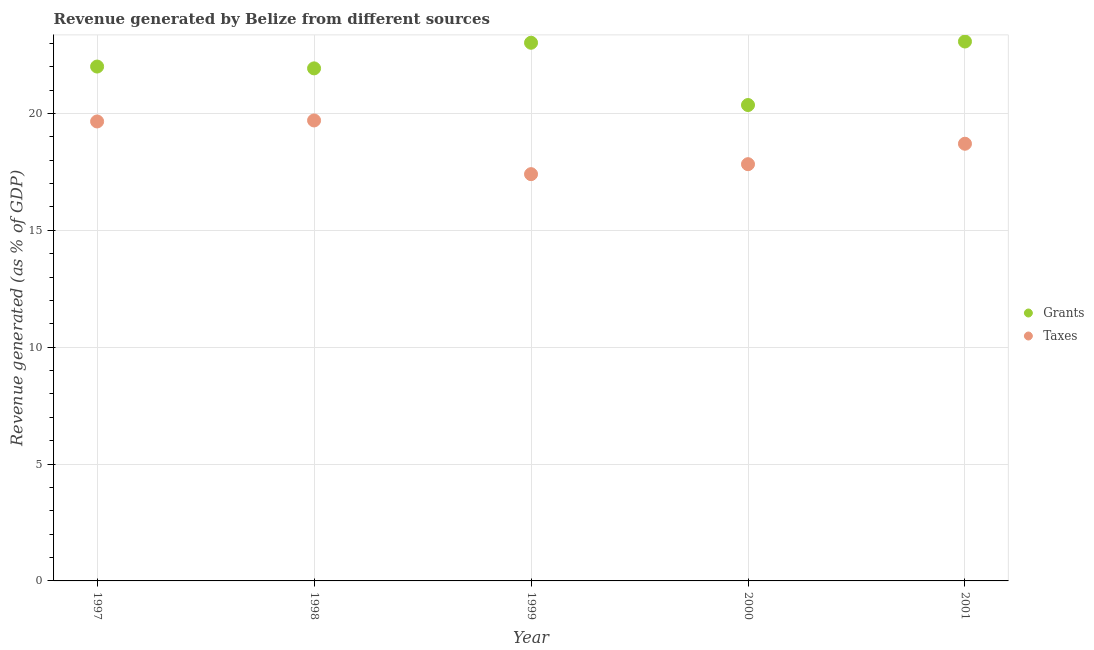What is the revenue generated by grants in 2000?
Offer a very short reply. 20.36. Across all years, what is the maximum revenue generated by taxes?
Offer a very short reply. 19.7. Across all years, what is the minimum revenue generated by grants?
Ensure brevity in your answer.  20.36. What is the total revenue generated by taxes in the graph?
Your response must be concise. 93.28. What is the difference between the revenue generated by grants in 1998 and that in 2001?
Your answer should be compact. -1.15. What is the difference between the revenue generated by taxes in 2001 and the revenue generated by grants in 1998?
Provide a short and direct response. -3.22. What is the average revenue generated by grants per year?
Offer a very short reply. 22.08. In the year 2001, what is the difference between the revenue generated by taxes and revenue generated by grants?
Provide a succinct answer. -4.37. In how many years, is the revenue generated by grants greater than 1 %?
Provide a succinct answer. 5. What is the ratio of the revenue generated by taxes in 2000 to that in 2001?
Give a very brief answer. 0.95. What is the difference between the highest and the second highest revenue generated by grants?
Your answer should be very brief. 0.05. What is the difference between the highest and the lowest revenue generated by grants?
Your answer should be compact. 2.72. Is the revenue generated by grants strictly less than the revenue generated by taxes over the years?
Provide a succinct answer. No. How many years are there in the graph?
Give a very brief answer. 5. What is the difference between two consecutive major ticks on the Y-axis?
Make the answer very short. 5. Are the values on the major ticks of Y-axis written in scientific E-notation?
Your response must be concise. No. Does the graph contain grids?
Ensure brevity in your answer.  Yes. Where does the legend appear in the graph?
Make the answer very short. Center right. How are the legend labels stacked?
Your answer should be very brief. Vertical. What is the title of the graph?
Provide a succinct answer. Revenue generated by Belize from different sources. Does "Nonresident" appear as one of the legend labels in the graph?
Provide a short and direct response. No. What is the label or title of the X-axis?
Ensure brevity in your answer.  Year. What is the label or title of the Y-axis?
Make the answer very short. Revenue generated (as % of GDP). What is the Revenue generated (as % of GDP) of Grants in 1997?
Your response must be concise. 22. What is the Revenue generated (as % of GDP) of Taxes in 1997?
Your response must be concise. 19.66. What is the Revenue generated (as % of GDP) of Grants in 1998?
Provide a short and direct response. 21.93. What is the Revenue generated (as % of GDP) in Taxes in 1998?
Provide a succinct answer. 19.7. What is the Revenue generated (as % of GDP) in Grants in 1999?
Ensure brevity in your answer.  23.02. What is the Revenue generated (as % of GDP) in Taxes in 1999?
Provide a short and direct response. 17.4. What is the Revenue generated (as % of GDP) in Grants in 2000?
Provide a short and direct response. 20.36. What is the Revenue generated (as % of GDP) of Taxes in 2000?
Offer a terse response. 17.83. What is the Revenue generated (as % of GDP) in Grants in 2001?
Provide a succinct answer. 23.08. What is the Revenue generated (as % of GDP) of Taxes in 2001?
Provide a short and direct response. 18.7. Across all years, what is the maximum Revenue generated (as % of GDP) in Grants?
Offer a terse response. 23.08. Across all years, what is the maximum Revenue generated (as % of GDP) of Taxes?
Ensure brevity in your answer.  19.7. Across all years, what is the minimum Revenue generated (as % of GDP) of Grants?
Your response must be concise. 20.36. Across all years, what is the minimum Revenue generated (as % of GDP) of Taxes?
Your response must be concise. 17.4. What is the total Revenue generated (as % of GDP) of Grants in the graph?
Provide a short and direct response. 110.39. What is the total Revenue generated (as % of GDP) in Taxes in the graph?
Make the answer very short. 93.28. What is the difference between the Revenue generated (as % of GDP) in Grants in 1997 and that in 1998?
Offer a terse response. 0.08. What is the difference between the Revenue generated (as % of GDP) of Taxes in 1997 and that in 1998?
Your response must be concise. -0.04. What is the difference between the Revenue generated (as % of GDP) of Grants in 1997 and that in 1999?
Offer a terse response. -1.02. What is the difference between the Revenue generated (as % of GDP) of Taxes in 1997 and that in 1999?
Your response must be concise. 2.25. What is the difference between the Revenue generated (as % of GDP) of Grants in 1997 and that in 2000?
Offer a very short reply. 1.65. What is the difference between the Revenue generated (as % of GDP) of Taxes in 1997 and that in 2000?
Offer a very short reply. 1.83. What is the difference between the Revenue generated (as % of GDP) of Grants in 1997 and that in 2001?
Provide a short and direct response. -1.07. What is the difference between the Revenue generated (as % of GDP) of Taxes in 1997 and that in 2001?
Give a very brief answer. 0.95. What is the difference between the Revenue generated (as % of GDP) of Grants in 1998 and that in 1999?
Your answer should be compact. -1.1. What is the difference between the Revenue generated (as % of GDP) of Taxes in 1998 and that in 1999?
Your answer should be very brief. 2.3. What is the difference between the Revenue generated (as % of GDP) in Grants in 1998 and that in 2000?
Keep it short and to the point. 1.57. What is the difference between the Revenue generated (as % of GDP) in Taxes in 1998 and that in 2000?
Make the answer very short. 1.87. What is the difference between the Revenue generated (as % of GDP) of Grants in 1998 and that in 2001?
Ensure brevity in your answer.  -1.15. What is the difference between the Revenue generated (as % of GDP) in Grants in 1999 and that in 2000?
Offer a very short reply. 2.66. What is the difference between the Revenue generated (as % of GDP) of Taxes in 1999 and that in 2000?
Ensure brevity in your answer.  -0.43. What is the difference between the Revenue generated (as % of GDP) of Grants in 1999 and that in 2001?
Provide a short and direct response. -0.05. What is the difference between the Revenue generated (as % of GDP) of Taxes in 1999 and that in 2001?
Your response must be concise. -1.3. What is the difference between the Revenue generated (as % of GDP) of Grants in 2000 and that in 2001?
Make the answer very short. -2.72. What is the difference between the Revenue generated (as % of GDP) of Taxes in 2000 and that in 2001?
Offer a very short reply. -0.87. What is the difference between the Revenue generated (as % of GDP) in Grants in 1997 and the Revenue generated (as % of GDP) in Taxes in 1998?
Your answer should be compact. 2.31. What is the difference between the Revenue generated (as % of GDP) in Grants in 1997 and the Revenue generated (as % of GDP) in Taxes in 1999?
Your response must be concise. 4.6. What is the difference between the Revenue generated (as % of GDP) of Grants in 1997 and the Revenue generated (as % of GDP) of Taxes in 2000?
Provide a succinct answer. 4.18. What is the difference between the Revenue generated (as % of GDP) of Grants in 1997 and the Revenue generated (as % of GDP) of Taxes in 2001?
Make the answer very short. 3.3. What is the difference between the Revenue generated (as % of GDP) in Grants in 1998 and the Revenue generated (as % of GDP) in Taxes in 1999?
Keep it short and to the point. 4.52. What is the difference between the Revenue generated (as % of GDP) in Grants in 1998 and the Revenue generated (as % of GDP) in Taxes in 2000?
Your answer should be very brief. 4.1. What is the difference between the Revenue generated (as % of GDP) in Grants in 1998 and the Revenue generated (as % of GDP) in Taxes in 2001?
Ensure brevity in your answer.  3.22. What is the difference between the Revenue generated (as % of GDP) of Grants in 1999 and the Revenue generated (as % of GDP) of Taxes in 2000?
Ensure brevity in your answer.  5.19. What is the difference between the Revenue generated (as % of GDP) in Grants in 1999 and the Revenue generated (as % of GDP) in Taxes in 2001?
Offer a very short reply. 4.32. What is the difference between the Revenue generated (as % of GDP) of Grants in 2000 and the Revenue generated (as % of GDP) of Taxes in 2001?
Ensure brevity in your answer.  1.66. What is the average Revenue generated (as % of GDP) in Grants per year?
Ensure brevity in your answer.  22.08. What is the average Revenue generated (as % of GDP) in Taxes per year?
Make the answer very short. 18.66. In the year 1997, what is the difference between the Revenue generated (as % of GDP) of Grants and Revenue generated (as % of GDP) of Taxes?
Provide a succinct answer. 2.35. In the year 1998, what is the difference between the Revenue generated (as % of GDP) in Grants and Revenue generated (as % of GDP) in Taxes?
Keep it short and to the point. 2.23. In the year 1999, what is the difference between the Revenue generated (as % of GDP) in Grants and Revenue generated (as % of GDP) in Taxes?
Offer a terse response. 5.62. In the year 2000, what is the difference between the Revenue generated (as % of GDP) of Grants and Revenue generated (as % of GDP) of Taxes?
Your answer should be very brief. 2.53. In the year 2001, what is the difference between the Revenue generated (as % of GDP) of Grants and Revenue generated (as % of GDP) of Taxes?
Offer a very short reply. 4.37. What is the ratio of the Revenue generated (as % of GDP) of Grants in 1997 to that in 1999?
Keep it short and to the point. 0.96. What is the ratio of the Revenue generated (as % of GDP) of Taxes in 1997 to that in 1999?
Offer a very short reply. 1.13. What is the ratio of the Revenue generated (as % of GDP) of Grants in 1997 to that in 2000?
Offer a very short reply. 1.08. What is the ratio of the Revenue generated (as % of GDP) in Taxes in 1997 to that in 2000?
Provide a succinct answer. 1.1. What is the ratio of the Revenue generated (as % of GDP) in Grants in 1997 to that in 2001?
Offer a very short reply. 0.95. What is the ratio of the Revenue generated (as % of GDP) of Taxes in 1997 to that in 2001?
Offer a very short reply. 1.05. What is the ratio of the Revenue generated (as % of GDP) in Grants in 1998 to that in 1999?
Ensure brevity in your answer.  0.95. What is the ratio of the Revenue generated (as % of GDP) of Taxes in 1998 to that in 1999?
Your response must be concise. 1.13. What is the ratio of the Revenue generated (as % of GDP) in Grants in 1998 to that in 2000?
Make the answer very short. 1.08. What is the ratio of the Revenue generated (as % of GDP) in Taxes in 1998 to that in 2000?
Your answer should be compact. 1.1. What is the ratio of the Revenue generated (as % of GDP) of Grants in 1998 to that in 2001?
Give a very brief answer. 0.95. What is the ratio of the Revenue generated (as % of GDP) of Taxes in 1998 to that in 2001?
Provide a succinct answer. 1.05. What is the ratio of the Revenue generated (as % of GDP) of Grants in 1999 to that in 2000?
Your answer should be compact. 1.13. What is the ratio of the Revenue generated (as % of GDP) in Taxes in 1999 to that in 2000?
Your answer should be compact. 0.98. What is the ratio of the Revenue generated (as % of GDP) of Taxes in 1999 to that in 2001?
Make the answer very short. 0.93. What is the ratio of the Revenue generated (as % of GDP) of Grants in 2000 to that in 2001?
Keep it short and to the point. 0.88. What is the ratio of the Revenue generated (as % of GDP) of Taxes in 2000 to that in 2001?
Offer a very short reply. 0.95. What is the difference between the highest and the second highest Revenue generated (as % of GDP) in Grants?
Keep it short and to the point. 0.05. What is the difference between the highest and the second highest Revenue generated (as % of GDP) in Taxes?
Offer a very short reply. 0.04. What is the difference between the highest and the lowest Revenue generated (as % of GDP) in Grants?
Your answer should be compact. 2.72. What is the difference between the highest and the lowest Revenue generated (as % of GDP) in Taxes?
Give a very brief answer. 2.3. 